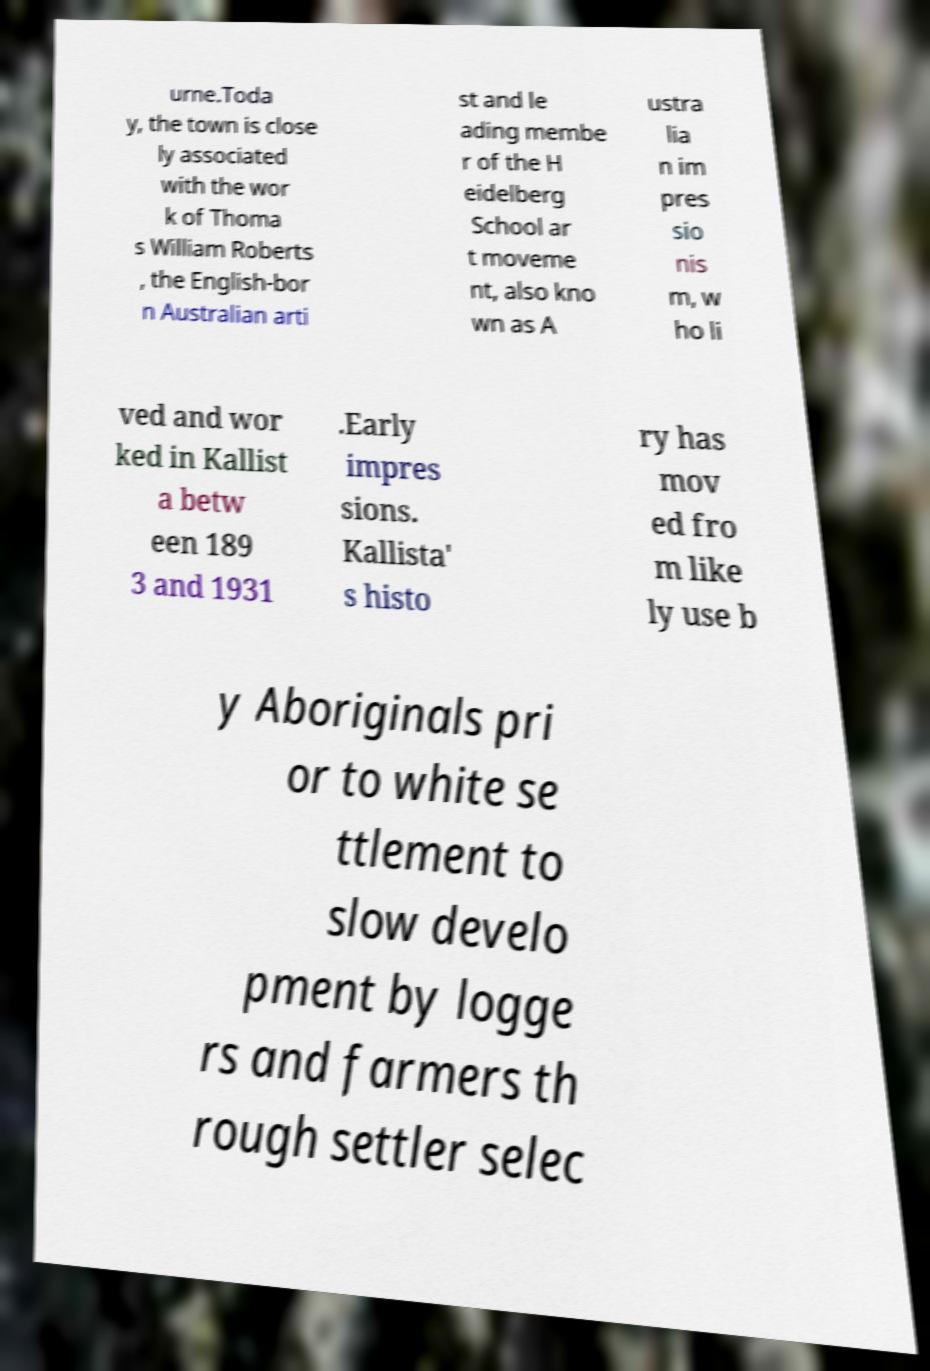There's text embedded in this image that I need extracted. Can you transcribe it verbatim? urne.Toda y, the town is close ly associated with the wor k of Thoma s William Roberts , the English-bor n Australian arti st and le ading membe r of the H eidelberg School ar t moveme nt, also kno wn as A ustra lia n im pres sio nis m, w ho li ved and wor ked in Kallist a betw een 189 3 and 1931 .Early impres sions. Kallista' s histo ry has mov ed fro m like ly use b y Aboriginals pri or to white se ttlement to slow develo pment by logge rs and farmers th rough settler selec 